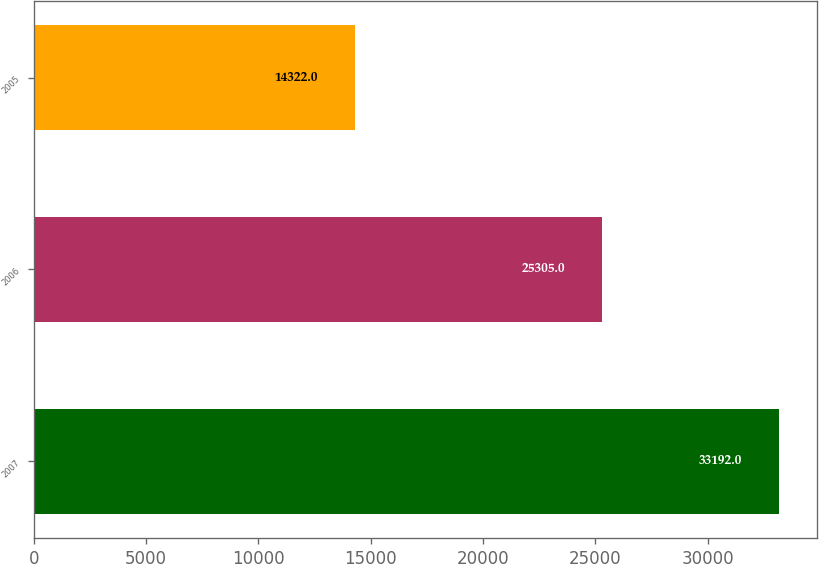Convert chart. <chart><loc_0><loc_0><loc_500><loc_500><bar_chart><fcel>2007<fcel>2006<fcel>2005<nl><fcel>33192<fcel>25305<fcel>14322<nl></chart> 